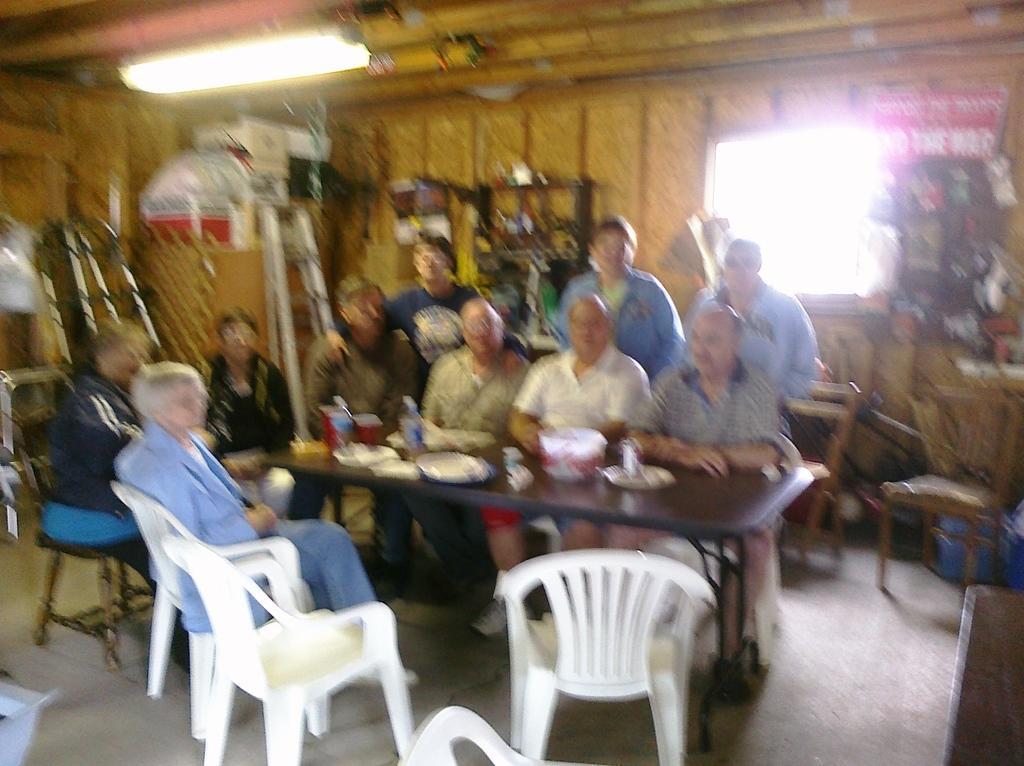In one or two sentences, can you explain what this image depicts? In this image i can see number of people sitting on chairs in front of a table and few people standing behind them, on the table I can see a bowl,few plates,few water bottles and few other objects. In the background I can see the wall, a window, the ladder, the ceiling and a light. 